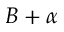Convert formula to latex. <formula><loc_0><loc_0><loc_500><loc_500>B + \alpha</formula> 